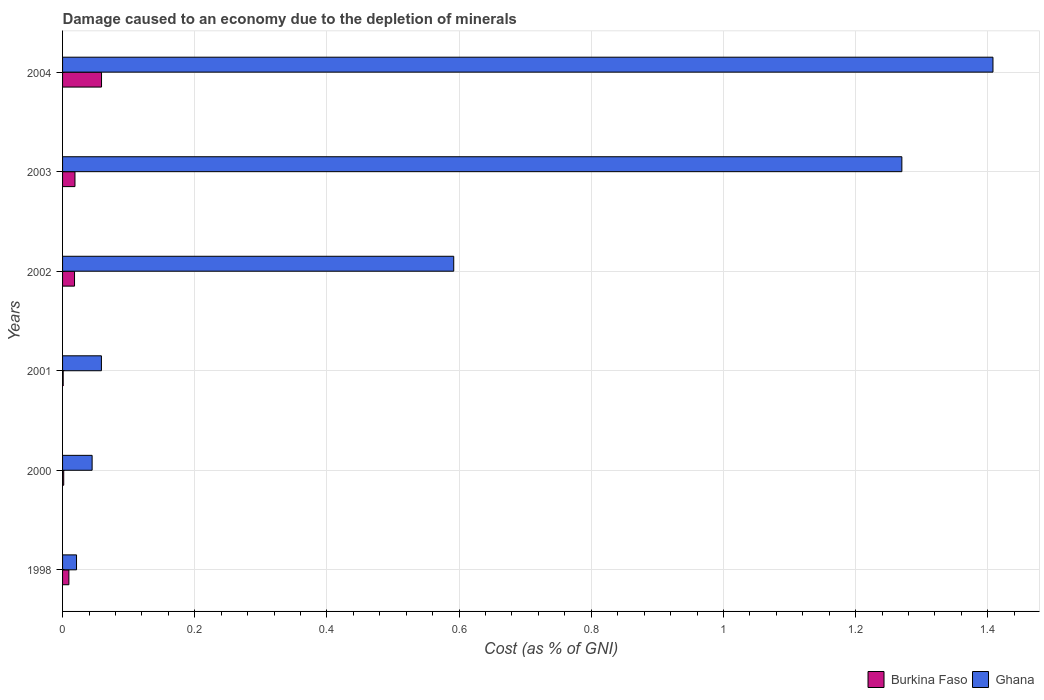How many groups of bars are there?
Offer a very short reply. 6. How many bars are there on the 4th tick from the top?
Keep it short and to the point. 2. How many bars are there on the 6th tick from the bottom?
Keep it short and to the point. 2. What is the cost of damage caused due to the depletion of minerals in Ghana in 2003?
Your response must be concise. 1.27. Across all years, what is the maximum cost of damage caused due to the depletion of minerals in Burkina Faso?
Make the answer very short. 0.06. Across all years, what is the minimum cost of damage caused due to the depletion of minerals in Ghana?
Ensure brevity in your answer.  0.02. In which year was the cost of damage caused due to the depletion of minerals in Burkina Faso minimum?
Keep it short and to the point. 2001. What is the total cost of damage caused due to the depletion of minerals in Ghana in the graph?
Keep it short and to the point. 3.39. What is the difference between the cost of damage caused due to the depletion of minerals in Ghana in 2000 and that in 2002?
Offer a terse response. -0.55. What is the difference between the cost of damage caused due to the depletion of minerals in Ghana in 1998 and the cost of damage caused due to the depletion of minerals in Burkina Faso in 2003?
Your answer should be compact. 0. What is the average cost of damage caused due to the depletion of minerals in Burkina Faso per year?
Offer a terse response. 0.02. In the year 1998, what is the difference between the cost of damage caused due to the depletion of minerals in Burkina Faso and cost of damage caused due to the depletion of minerals in Ghana?
Your response must be concise. -0.01. In how many years, is the cost of damage caused due to the depletion of minerals in Burkina Faso greater than 1.3200000000000003 %?
Ensure brevity in your answer.  0. What is the ratio of the cost of damage caused due to the depletion of minerals in Ghana in 2000 to that in 2004?
Offer a terse response. 0.03. What is the difference between the highest and the second highest cost of damage caused due to the depletion of minerals in Burkina Faso?
Your response must be concise. 0.04. What is the difference between the highest and the lowest cost of damage caused due to the depletion of minerals in Ghana?
Your answer should be compact. 1.39. In how many years, is the cost of damage caused due to the depletion of minerals in Ghana greater than the average cost of damage caused due to the depletion of minerals in Ghana taken over all years?
Your response must be concise. 3. What does the 2nd bar from the top in 2002 represents?
Your answer should be very brief. Burkina Faso. What does the 1st bar from the bottom in 2002 represents?
Ensure brevity in your answer.  Burkina Faso. How many bars are there?
Your response must be concise. 12. Are all the bars in the graph horizontal?
Make the answer very short. Yes. Are the values on the major ticks of X-axis written in scientific E-notation?
Your answer should be compact. No. Does the graph contain any zero values?
Keep it short and to the point. No. Does the graph contain grids?
Your answer should be very brief. Yes. What is the title of the graph?
Offer a very short reply. Damage caused to an economy due to the depletion of minerals. What is the label or title of the X-axis?
Offer a very short reply. Cost (as % of GNI). What is the label or title of the Y-axis?
Give a very brief answer. Years. What is the Cost (as % of GNI) in Burkina Faso in 1998?
Offer a very short reply. 0.01. What is the Cost (as % of GNI) of Ghana in 1998?
Your response must be concise. 0.02. What is the Cost (as % of GNI) of Burkina Faso in 2000?
Give a very brief answer. 0. What is the Cost (as % of GNI) in Ghana in 2000?
Ensure brevity in your answer.  0.04. What is the Cost (as % of GNI) in Burkina Faso in 2001?
Keep it short and to the point. 0. What is the Cost (as % of GNI) in Ghana in 2001?
Offer a very short reply. 0.06. What is the Cost (as % of GNI) in Burkina Faso in 2002?
Your answer should be compact. 0.02. What is the Cost (as % of GNI) of Ghana in 2002?
Your answer should be very brief. 0.59. What is the Cost (as % of GNI) in Burkina Faso in 2003?
Give a very brief answer. 0.02. What is the Cost (as % of GNI) in Ghana in 2003?
Your response must be concise. 1.27. What is the Cost (as % of GNI) in Burkina Faso in 2004?
Keep it short and to the point. 0.06. What is the Cost (as % of GNI) of Ghana in 2004?
Make the answer very short. 1.41. Across all years, what is the maximum Cost (as % of GNI) in Burkina Faso?
Offer a terse response. 0.06. Across all years, what is the maximum Cost (as % of GNI) of Ghana?
Give a very brief answer. 1.41. Across all years, what is the minimum Cost (as % of GNI) in Burkina Faso?
Make the answer very short. 0. Across all years, what is the minimum Cost (as % of GNI) in Ghana?
Offer a terse response. 0.02. What is the total Cost (as % of GNI) in Burkina Faso in the graph?
Your answer should be very brief. 0.11. What is the total Cost (as % of GNI) of Ghana in the graph?
Offer a terse response. 3.39. What is the difference between the Cost (as % of GNI) of Burkina Faso in 1998 and that in 2000?
Make the answer very short. 0.01. What is the difference between the Cost (as % of GNI) in Ghana in 1998 and that in 2000?
Make the answer very short. -0.02. What is the difference between the Cost (as % of GNI) of Burkina Faso in 1998 and that in 2001?
Make the answer very short. 0.01. What is the difference between the Cost (as % of GNI) of Ghana in 1998 and that in 2001?
Offer a very short reply. -0.04. What is the difference between the Cost (as % of GNI) in Burkina Faso in 1998 and that in 2002?
Ensure brevity in your answer.  -0.01. What is the difference between the Cost (as % of GNI) in Ghana in 1998 and that in 2002?
Give a very brief answer. -0.57. What is the difference between the Cost (as % of GNI) in Burkina Faso in 1998 and that in 2003?
Ensure brevity in your answer.  -0.01. What is the difference between the Cost (as % of GNI) of Ghana in 1998 and that in 2003?
Provide a short and direct response. -1.25. What is the difference between the Cost (as % of GNI) of Burkina Faso in 1998 and that in 2004?
Provide a succinct answer. -0.05. What is the difference between the Cost (as % of GNI) of Ghana in 1998 and that in 2004?
Your answer should be compact. -1.39. What is the difference between the Cost (as % of GNI) of Burkina Faso in 2000 and that in 2001?
Make the answer very short. 0. What is the difference between the Cost (as % of GNI) of Ghana in 2000 and that in 2001?
Your answer should be compact. -0.01. What is the difference between the Cost (as % of GNI) of Burkina Faso in 2000 and that in 2002?
Keep it short and to the point. -0.02. What is the difference between the Cost (as % of GNI) in Ghana in 2000 and that in 2002?
Your answer should be very brief. -0.55. What is the difference between the Cost (as % of GNI) in Burkina Faso in 2000 and that in 2003?
Provide a succinct answer. -0.02. What is the difference between the Cost (as % of GNI) in Ghana in 2000 and that in 2003?
Your answer should be very brief. -1.23. What is the difference between the Cost (as % of GNI) of Burkina Faso in 2000 and that in 2004?
Your answer should be very brief. -0.06. What is the difference between the Cost (as % of GNI) in Ghana in 2000 and that in 2004?
Offer a very short reply. -1.36. What is the difference between the Cost (as % of GNI) of Burkina Faso in 2001 and that in 2002?
Ensure brevity in your answer.  -0.02. What is the difference between the Cost (as % of GNI) of Ghana in 2001 and that in 2002?
Provide a short and direct response. -0.53. What is the difference between the Cost (as % of GNI) of Burkina Faso in 2001 and that in 2003?
Offer a very short reply. -0.02. What is the difference between the Cost (as % of GNI) in Ghana in 2001 and that in 2003?
Ensure brevity in your answer.  -1.21. What is the difference between the Cost (as % of GNI) of Burkina Faso in 2001 and that in 2004?
Offer a terse response. -0.06. What is the difference between the Cost (as % of GNI) of Ghana in 2001 and that in 2004?
Make the answer very short. -1.35. What is the difference between the Cost (as % of GNI) of Burkina Faso in 2002 and that in 2003?
Provide a succinct answer. -0. What is the difference between the Cost (as % of GNI) in Ghana in 2002 and that in 2003?
Your answer should be compact. -0.68. What is the difference between the Cost (as % of GNI) of Burkina Faso in 2002 and that in 2004?
Give a very brief answer. -0.04. What is the difference between the Cost (as % of GNI) of Ghana in 2002 and that in 2004?
Give a very brief answer. -0.82. What is the difference between the Cost (as % of GNI) of Burkina Faso in 2003 and that in 2004?
Your answer should be compact. -0.04. What is the difference between the Cost (as % of GNI) of Ghana in 2003 and that in 2004?
Your response must be concise. -0.14. What is the difference between the Cost (as % of GNI) of Burkina Faso in 1998 and the Cost (as % of GNI) of Ghana in 2000?
Provide a short and direct response. -0.04. What is the difference between the Cost (as % of GNI) in Burkina Faso in 1998 and the Cost (as % of GNI) in Ghana in 2001?
Make the answer very short. -0.05. What is the difference between the Cost (as % of GNI) of Burkina Faso in 1998 and the Cost (as % of GNI) of Ghana in 2002?
Offer a very short reply. -0.58. What is the difference between the Cost (as % of GNI) in Burkina Faso in 1998 and the Cost (as % of GNI) in Ghana in 2003?
Provide a short and direct response. -1.26. What is the difference between the Cost (as % of GNI) in Burkina Faso in 1998 and the Cost (as % of GNI) in Ghana in 2004?
Provide a short and direct response. -1.4. What is the difference between the Cost (as % of GNI) in Burkina Faso in 2000 and the Cost (as % of GNI) in Ghana in 2001?
Keep it short and to the point. -0.06. What is the difference between the Cost (as % of GNI) in Burkina Faso in 2000 and the Cost (as % of GNI) in Ghana in 2002?
Provide a short and direct response. -0.59. What is the difference between the Cost (as % of GNI) of Burkina Faso in 2000 and the Cost (as % of GNI) of Ghana in 2003?
Provide a short and direct response. -1.27. What is the difference between the Cost (as % of GNI) of Burkina Faso in 2000 and the Cost (as % of GNI) of Ghana in 2004?
Give a very brief answer. -1.41. What is the difference between the Cost (as % of GNI) of Burkina Faso in 2001 and the Cost (as % of GNI) of Ghana in 2002?
Give a very brief answer. -0.59. What is the difference between the Cost (as % of GNI) of Burkina Faso in 2001 and the Cost (as % of GNI) of Ghana in 2003?
Your response must be concise. -1.27. What is the difference between the Cost (as % of GNI) in Burkina Faso in 2001 and the Cost (as % of GNI) in Ghana in 2004?
Ensure brevity in your answer.  -1.41. What is the difference between the Cost (as % of GNI) in Burkina Faso in 2002 and the Cost (as % of GNI) in Ghana in 2003?
Your answer should be compact. -1.25. What is the difference between the Cost (as % of GNI) in Burkina Faso in 2002 and the Cost (as % of GNI) in Ghana in 2004?
Offer a very short reply. -1.39. What is the difference between the Cost (as % of GNI) of Burkina Faso in 2003 and the Cost (as % of GNI) of Ghana in 2004?
Offer a very short reply. -1.39. What is the average Cost (as % of GNI) in Burkina Faso per year?
Make the answer very short. 0.02. What is the average Cost (as % of GNI) in Ghana per year?
Your answer should be very brief. 0.57. In the year 1998, what is the difference between the Cost (as % of GNI) in Burkina Faso and Cost (as % of GNI) in Ghana?
Your answer should be very brief. -0.01. In the year 2000, what is the difference between the Cost (as % of GNI) of Burkina Faso and Cost (as % of GNI) of Ghana?
Provide a short and direct response. -0.04. In the year 2001, what is the difference between the Cost (as % of GNI) in Burkina Faso and Cost (as % of GNI) in Ghana?
Provide a succinct answer. -0.06. In the year 2002, what is the difference between the Cost (as % of GNI) of Burkina Faso and Cost (as % of GNI) of Ghana?
Your response must be concise. -0.57. In the year 2003, what is the difference between the Cost (as % of GNI) in Burkina Faso and Cost (as % of GNI) in Ghana?
Your response must be concise. -1.25. In the year 2004, what is the difference between the Cost (as % of GNI) of Burkina Faso and Cost (as % of GNI) of Ghana?
Your answer should be compact. -1.35. What is the ratio of the Cost (as % of GNI) of Burkina Faso in 1998 to that in 2000?
Provide a succinct answer. 5.51. What is the ratio of the Cost (as % of GNI) in Ghana in 1998 to that in 2000?
Your response must be concise. 0.47. What is the ratio of the Cost (as % of GNI) in Burkina Faso in 1998 to that in 2001?
Provide a short and direct response. 10.07. What is the ratio of the Cost (as % of GNI) in Ghana in 1998 to that in 2001?
Your answer should be very brief. 0.36. What is the ratio of the Cost (as % of GNI) in Burkina Faso in 1998 to that in 2002?
Your answer should be compact. 0.53. What is the ratio of the Cost (as % of GNI) in Ghana in 1998 to that in 2002?
Ensure brevity in your answer.  0.04. What is the ratio of the Cost (as % of GNI) of Burkina Faso in 1998 to that in 2003?
Your response must be concise. 0.51. What is the ratio of the Cost (as % of GNI) in Ghana in 1998 to that in 2003?
Provide a succinct answer. 0.02. What is the ratio of the Cost (as % of GNI) of Burkina Faso in 1998 to that in 2004?
Offer a very short reply. 0.16. What is the ratio of the Cost (as % of GNI) in Ghana in 1998 to that in 2004?
Keep it short and to the point. 0.01. What is the ratio of the Cost (as % of GNI) of Burkina Faso in 2000 to that in 2001?
Your response must be concise. 1.83. What is the ratio of the Cost (as % of GNI) of Ghana in 2000 to that in 2001?
Ensure brevity in your answer.  0.76. What is the ratio of the Cost (as % of GNI) in Burkina Faso in 2000 to that in 2002?
Give a very brief answer. 0.1. What is the ratio of the Cost (as % of GNI) of Ghana in 2000 to that in 2002?
Your response must be concise. 0.08. What is the ratio of the Cost (as % of GNI) of Burkina Faso in 2000 to that in 2003?
Keep it short and to the point. 0.09. What is the ratio of the Cost (as % of GNI) of Ghana in 2000 to that in 2003?
Give a very brief answer. 0.04. What is the ratio of the Cost (as % of GNI) in Burkina Faso in 2000 to that in 2004?
Your answer should be compact. 0.03. What is the ratio of the Cost (as % of GNI) of Ghana in 2000 to that in 2004?
Ensure brevity in your answer.  0.03. What is the ratio of the Cost (as % of GNI) of Burkina Faso in 2001 to that in 2002?
Give a very brief answer. 0.05. What is the ratio of the Cost (as % of GNI) of Ghana in 2001 to that in 2002?
Give a very brief answer. 0.1. What is the ratio of the Cost (as % of GNI) in Burkina Faso in 2001 to that in 2003?
Keep it short and to the point. 0.05. What is the ratio of the Cost (as % of GNI) of Ghana in 2001 to that in 2003?
Your answer should be very brief. 0.05. What is the ratio of the Cost (as % of GNI) in Burkina Faso in 2001 to that in 2004?
Provide a short and direct response. 0.02. What is the ratio of the Cost (as % of GNI) in Ghana in 2001 to that in 2004?
Keep it short and to the point. 0.04. What is the ratio of the Cost (as % of GNI) of Burkina Faso in 2002 to that in 2003?
Give a very brief answer. 0.97. What is the ratio of the Cost (as % of GNI) of Ghana in 2002 to that in 2003?
Your response must be concise. 0.47. What is the ratio of the Cost (as % of GNI) of Burkina Faso in 2002 to that in 2004?
Provide a succinct answer. 0.31. What is the ratio of the Cost (as % of GNI) in Ghana in 2002 to that in 2004?
Keep it short and to the point. 0.42. What is the ratio of the Cost (as % of GNI) in Burkina Faso in 2003 to that in 2004?
Offer a terse response. 0.32. What is the ratio of the Cost (as % of GNI) in Ghana in 2003 to that in 2004?
Ensure brevity in your answer.  0.9. What is the difference between the highest and the second highest Cost (as % of GNI) of Burkina Faso?
Offer a terse response. 0.04. What is the difference between the highest and the second highest Cost (as % of GNI) of Ghana?
Keep it short and to the point. 0.14. What is the difference between the highest and the lowest Cost (as % of GNI) in Burkina Faso?
Your answer should be compact. 0.06. What is the difference between the highest and the lowest Cost (as % of GNI) of Ghana?
Offer a terse response. 1.39. 